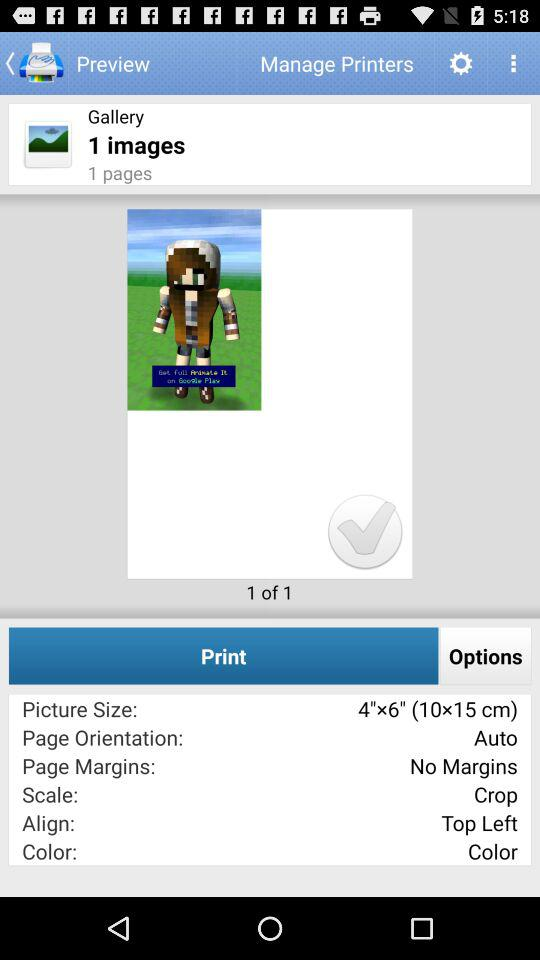What is the picture size? The picture size is 4" x 6" (10 x 15 cm). 